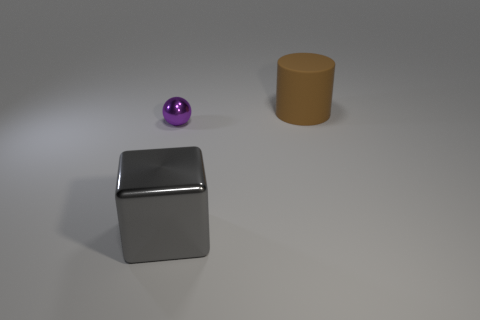Add 3 rubber things. How many objects exist? 6 Subtract all spheres. How many objects are left? 2 Add 3 tiny purple shiny objects. How many tiny purple shiny objects exist? 4 Subtract 0 blue balls. How many objects are left? 3 Subtract all purple metal objects. Subtract all big green shiny cylinders. How many objects are left? 2 Add 3 shiny blocks. How many shiny blocks are left? 4 